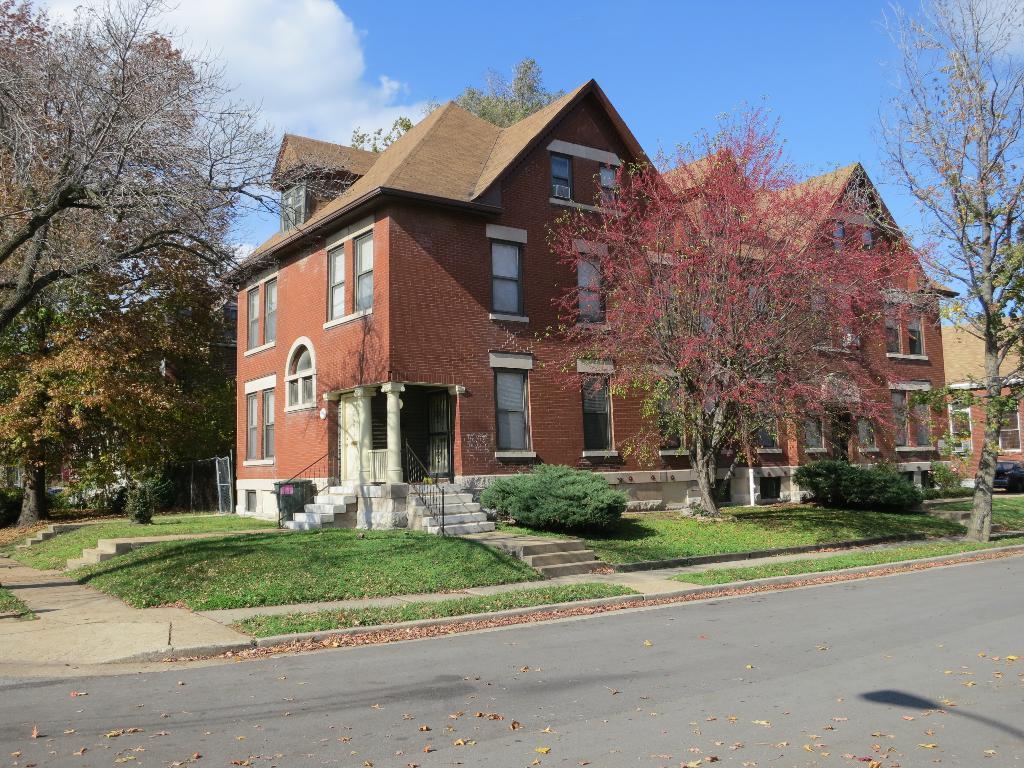Please provide a concise description of this image. In this image we can see the road, dry leaves, grass, shrubs, stairs, house, trees and the sky with clouds in the background. 